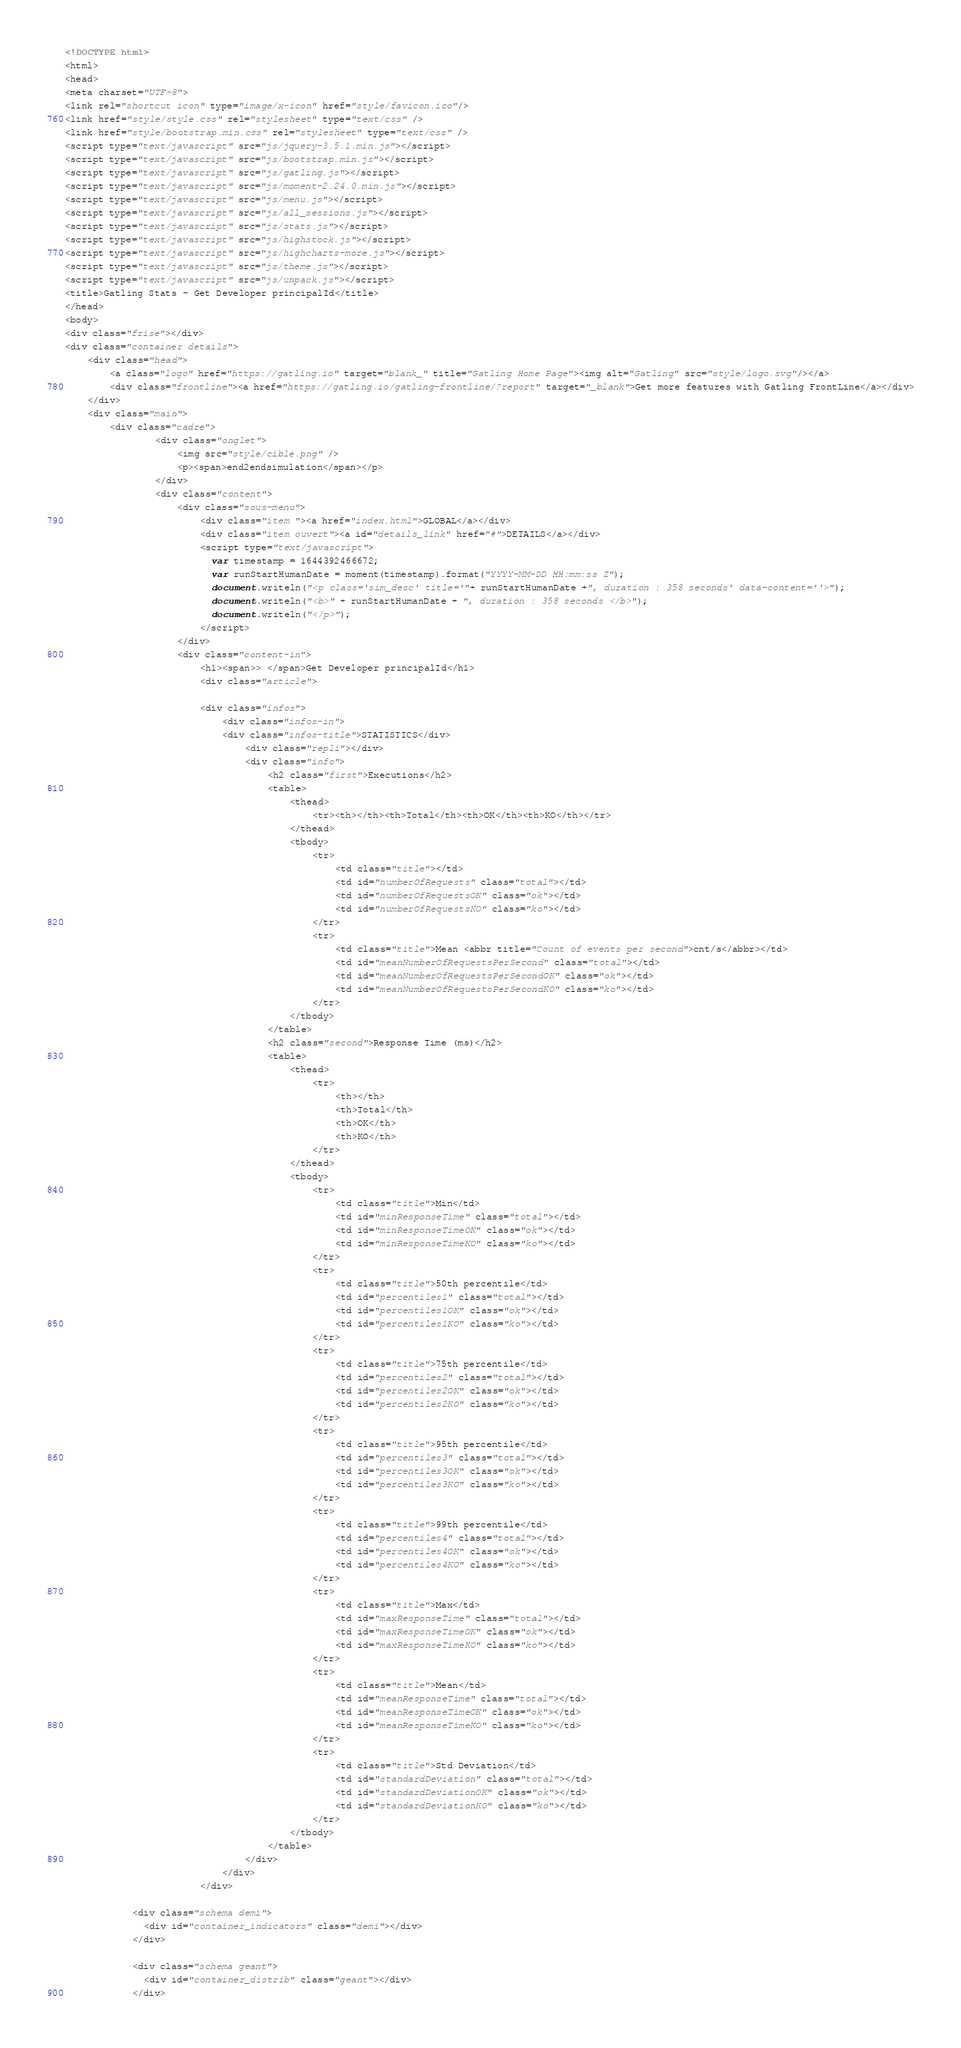Convert code to text. <code><loc_0><loc_0><loc_500><loc_500><_HTML_>
<!DOCTYPE html>
<html>
<head>
<meta charset="UTF-8">
<link rel="shortcut icon" type="image/x-icon" href="style/favicon.ico"/>
<link href="style/style.css" rel="stylesheet" type="text/css" />
<link href="style/bootstrap.min.css" rel="stylesheet" type="text/css" />
<script type="text/javascript" src="js/jquery-3.5.1.min.js"></script>
<script type="text/javascript" src="js/bootstrap.min.js"></script>
<script type="text/javascript" src="js/gatling.js"></script>
<script type="text/javascript" src="js/moment-2.24.0.min.js"></script>
<script type="text/javascript" src="js/menu.js"></script>
<script type="text/javascript" src="js/all_sessions.js"></script>
<script type="text/javascript" src="js/stats.js"></script>
<script type="text/javascript" src="js/highstock.js"></script>
<script type="text/javascript" src="js/highcharts-more.js"></script>
<script type="text/javascript" src="js/theme.js"></script>
<script type="text/javascript" src="js/unpack.js"></script>
<title>Gatling Stats - Get Developer principalId</title>
</head>
<body>
<div class="frise"></div>
<div class="container details">
    <div class="head">
        <a class="logo" href="https://gatling.io" target="blank_" title="Gatling Home Page"><img alt="Gatling" src="style/logo.svg"/></a>
        <div class="frontline"><a href="https://gatling.io/gatling-frontline/?report" target="_blank">Get more features with Gatling FrontLine</a></div>
    </div>
    <div class="main">
        <div class="cadre">
                <div class="onglet">
                    <img src="style/cible.png" />
                    <p><span>end2endsimulation</span></p>
                </div>
                <div class="content">
                    <div class="sous-menu">
                        <div class="item "><a href="index.html">GLOBAL</a></div>
                        <div class="item ouvert"><a id="details_link" href="#">DETAILS</a></div>
                        <script type="text/javascript">
                          var timestamp = 1644392466672;
                          var runStartHumanDate = moment(timestamp).format("YYYY-MM-DD HH:mm:ss Z");
                          document.writeln("<p class='sim_desc' title='"+ runStartHumanDate +", duration : 358 seconds' data-content=''>");
                          document.writeln("<b>" + runStartHumanDate + ", duration : 358 seconds </b>");
                          document.writeln("</p>");
                        </script>
                    </div>
                    <div class="content-in">
                        <h1><span>> </span>Get Developer principalId</h1>
                        <div class="article">
                            
                        <div class="infos">
                            <div class="infos-in">
	                        <div class="infos-title">STATISTICS</div>
                                <div class="repli"></div>                               
                                <div class="info">
                                    <h2 class="first">Executions</h2>
                                    <table>
                                        <thead>
                                            <tr><th></th><th>Total</th><th>OK</th><th>KO</th></tr>
                                        </thead>
                                        <tbody>
                                            <tr>
                                                <td class="title"></td>
                                                <td id="numberOfRequests" class="total"></td>
                                                <td id="numberOfRequestsOK" class="ok"></td>
                                                <td id="numberOfRequestsKO" class="ko"></td>
                                            </tr>
                                            <tr>
                                                <td class="title">Mean <abbr title="Count of events per second">cnt/s</abbr></td>
                                                <td id="meanNumberOfRequestsPerSecond" class="total"></td>
                                                <td id="meanNumberOfRequestsPerSecondOK" class="ok"></td>
                                                <td id="meanNumberOfRequestsPerSecondKO" class="ko"></td>
                                            </tr>
                                        </tbody>
                                    </table>
                                    <h2 class="second">Response Time (ms)</h2>
                                    <table>
                                        <thead>
                                            <tr>
                                                <th></th>
                                                <th>Total</th>
                                                <th>OK</th>
                                                <th>KO</th>
                                            </tr>
                                        </thead>
                                        <tbody>
                                            <tr>
                                                <td class="title">Min</td>
                                                <td id="minResponseTime" class="total"></td>
                                                <td id="minResponseTimeOK" class="ok"></td>
                                                <td id="minResponseTimeKO" class="ko"></td>
                                            </tr>
                                            <tr>
                                                <td class="title">50th percentile</td>
                                                <td id="percentiles1" class="total"></td>
                                                <td id="percentiles1OK" class="ok"></td>
                                                <td id="percentiles1KO" class="ko"></td>
                                            </tr>
                                            <tr>
                                                <td class="title">75th percentile</td>
                                                <td id="percentiles2" class="total"></td>
                                                <td id="percentiles2OK" class="ok"></td>
                                                <td id="percentiles2KO" class="ko"></td>
                                            </tr>
                                            <tr>
                                                <td class="title">95th percentile</td>
                                                <td id="percentiles3" class="total"></td>
                                                <td id="percentiles3OK" class="ok"></td>
                                                <td id="percentiles3KO" class="ko"></td>
                                            </tr>
                                            <tr>
                                                <td class="title">99th percentile</td>
                                                <td id="percentiles4" class="total"></td>
                                                <td id="percentiles4OK" class="ok"></td>
                                                <td id="percentiles4KO" class="ko"></td>
                                            </tr>
                                            <tr>
                                                <td class="title">Max</td>
                                                <td id="maxResponseTime" class="total"></td>
                                                <td id="maxResponseTimeOK" class="ok"></td>
                                                <td id="maxResponseTimeKO" class="ko"></td>
                                            </tr>
                                            <tr>
                                                <td class="title">Mean</td>
                                                <td id="meanResponseTime" class="total"></td>
                                                <td id="meanResponseTimeOK" class="ok"></td>
                                                <td id="meanResponseTimeKO" class="ko"></td>
                                            </tr>
                                            <tr>
                                                <td class="title">Std Deviation</td>
                                                <td id="standardDeviation" class="total"></td>
                                                <td id="standardDeviationOK" class="ok"></td>
                                                <td id="standardDeviationKO" class="ko"></td>
                                            </tr>
                                        </tbody>
                                    </table>
                                </div>
                            </div>
                        </div>

            <div class="schema demi">
              <div id="container_indicators" class="demi"></div>
            </div>

            <div class="schema geant">
              <div id="container_distrib" class="geant"></div>
            </div>
</code> 